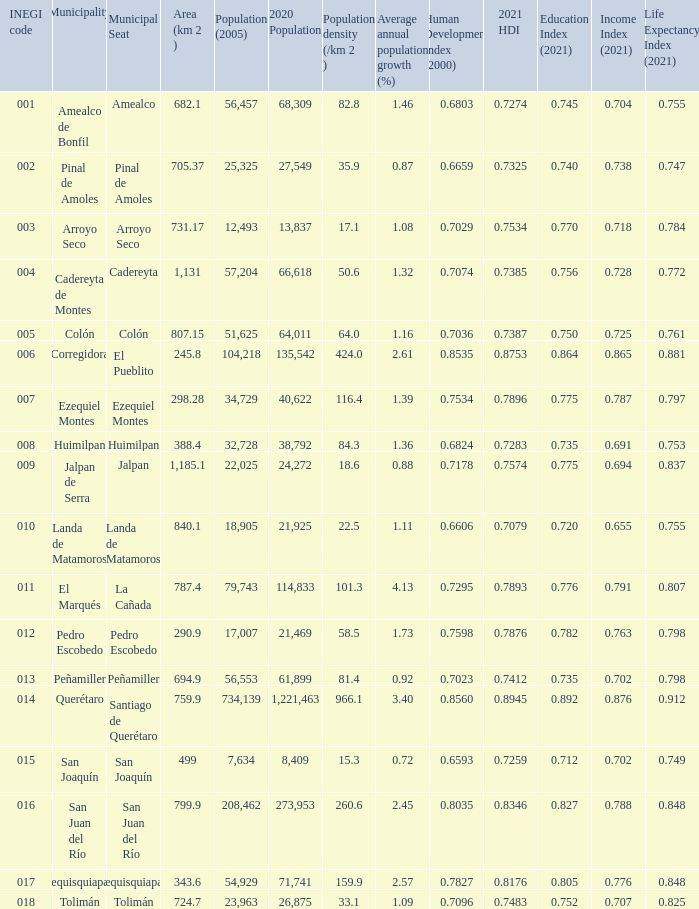Which Area (km 2 )has a Population (2005) of 57,204, and a Human Development Index (2000) smaller than 0.7074? 0.0. 